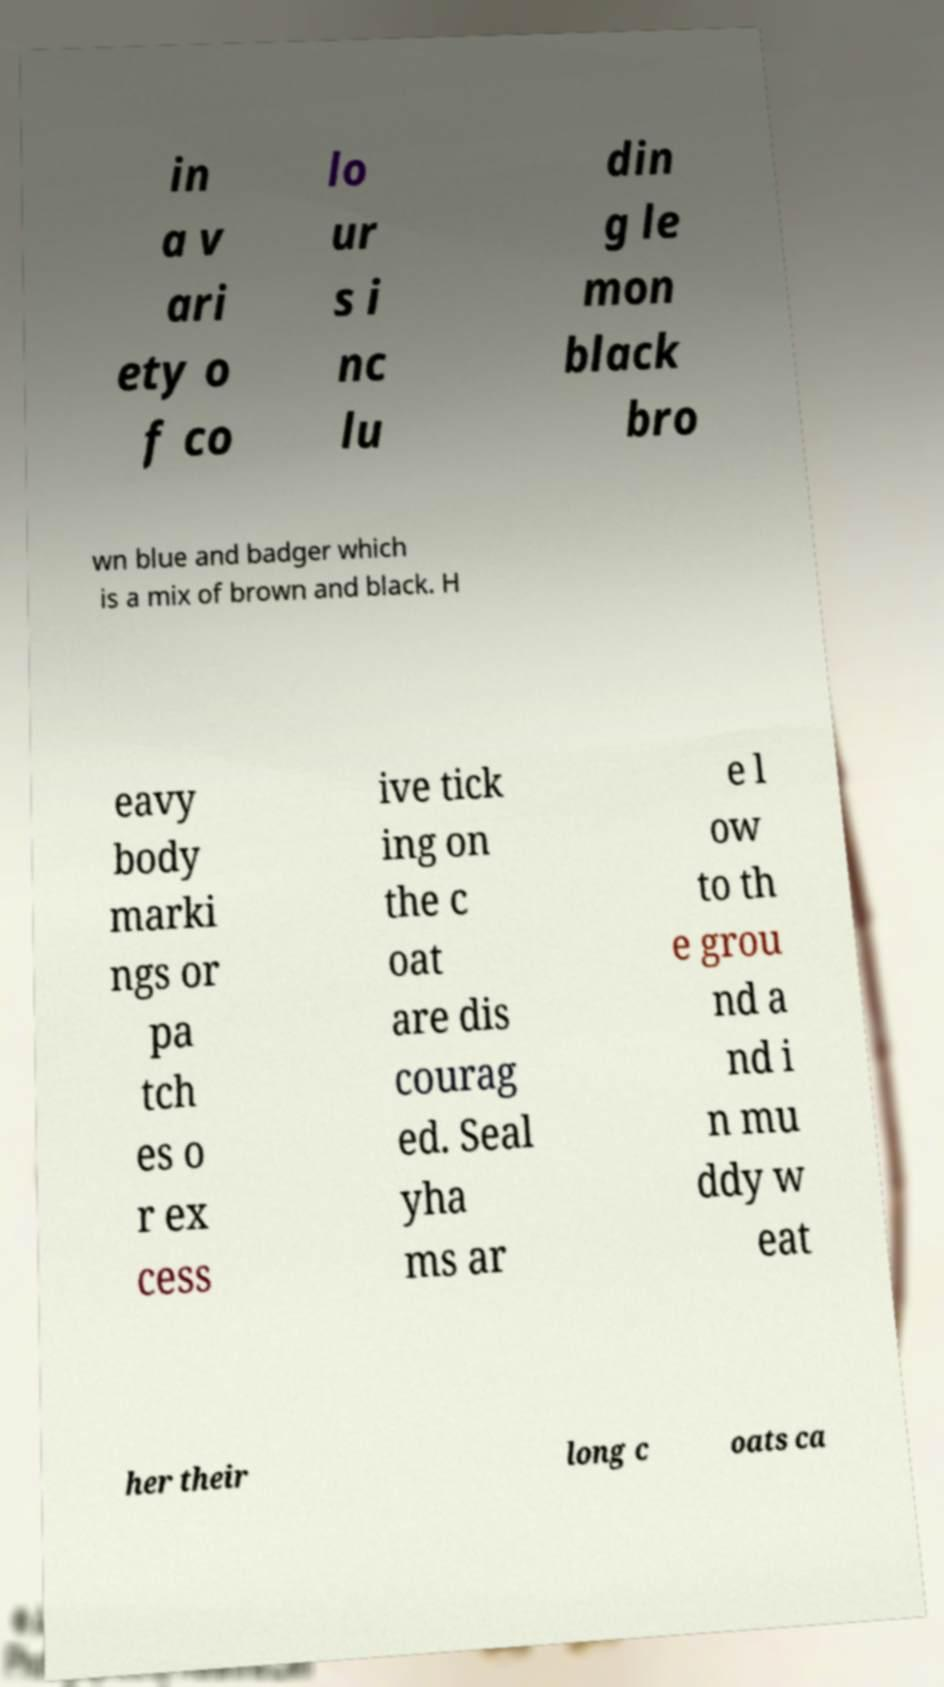Can you read and provide the text displayed in the image?This photo seems to have some interesting text. Can you extract and type it out for me? in a v ari ety o f co lo ur s i nc lu din g le mon black bro wn blue and badger which is a mix of brown and black. H eavy body marki ngs or pa tch es o r ex cess ive tick ing on the c oat are dis courag ed. Seal yha ms ar e l ow to th e grou nd a nd i n mu ddy w eat her their long c oats ca 